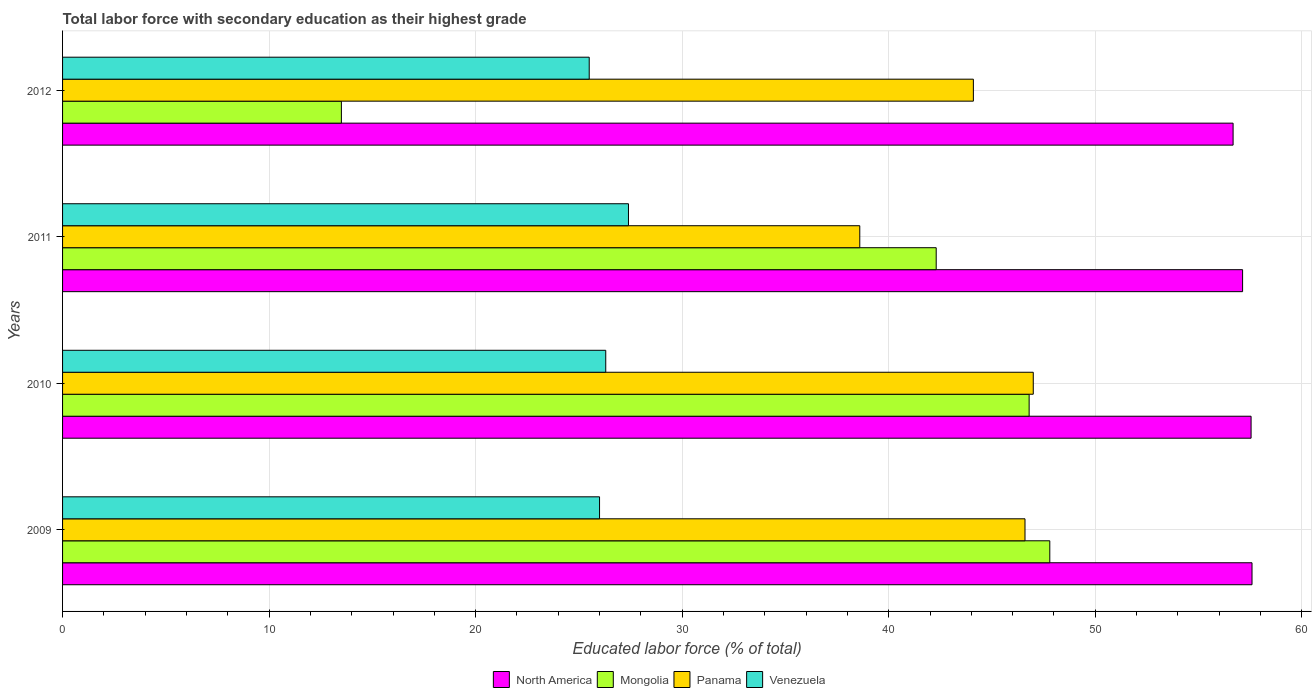Are the number of bars per tick equal to the number of legend labels?
Give a very brief answer. Yes. How many bars are there on the 3rd tick from the top?
Keep it short and to the point. 4. How many bars are there on the 1st tick from the bottom?
Make the answer very short. 4. In how many cases, is the number of bars for a given year not equal to the number of legend labels?
Your answer should be very brief. 0. What is the percentage of total labor force with primary education in Venezuela in 2011?
Give a very brief answer. 27.4. Across all years, what is the minimum percentage of total labor force with primary education in Mongolia?
Your response must be concise. 13.5. In which year was the percentage of total labor force with primary education in Panama minimum?
Ensure brevity in your answer.  2011. What is the total percentage of total labor force with primary education in Mongolia in the graph?
Keep it short and to the point. 150.4. What is the difference between the percentage of total labor force with primary education in North America in 2009 and the percentage of total labor force with primary education in Mongolia in 2012?
Ensure brevity in your answer.  44.09. What is the average percentage of total labor force with primary education in Panama per year?
Keep it short and to the point. 44.07. In the year 2010, what is the difference between the percentage of total labor force with primary education in Panama and percentage of total labor force with primary education in Mongolia?
Ensure brevity in your answer.  0.2. What is the ratio of the percentage of total labor force with primary education in Mongolia in 2009 to that in 2012?
Your answer should be compact. 3.54. Is the percentage of total labor force with primary education in Venezuela in 2010 less than that in 2012?
Ensure brevity in your answer.  No. What is the difference between the highest and the second highest percentage of total labor force with primary education in Panama?
Your answer should be compact. 0.4. What is the difference between the highest and the lowest percentage of total labor force with primary education in Mongolia?
Give a very brief answer. 34.3. What does the 3rd bar from the top in 2011 represents?
Offer a very short reply. Mongolia. What does the 3rd bar from the bottom in 2012 represents?
Provide a short and direct response. Panama. Are all the bars in the graph horizontal?
Your response must be concise. Yes. How many years are there in the graph?
Offer a terse response. 4. What is the difference between two consecutive major ticks on the X-axis?
Provide a succinct answer. 10. Does the graph contain any zero values?
Your answer should be very brief. No. Does the graph contain grids?
Provide a succinct answer. Yes. How many legend labels are there?
Provide a succinct answer. 4. How are the legend labels stacked?
Keep it short and to the point. Horizontal. What is the title of the graph?
Your response must be concise. Total labor force with secondary education as their highest grade. What is the label or title of the X-axis?
Your answer should be very brief. Educated labor force (% of total). What is the Educated labor force (% of total) of North America in 2009?
Give a very brief answer. 57.59. What is the Educated labor force (% of total) of Mongolia in 2009?
Your answer should be compact. 47.8. What is the Educated labor force (% of total) of Panama in 2009?
Your answer should be compact. 46.6. What is the Educated labor force (% of total) of North America in 2010?
Offer a very short reply. 57.55. What is the Educated labor force (% of total) in Mongolia in 2010?
Offer a very short reply. 46.8. What is the Educated labor force (% of total) in Panama in 2010?
Your response must be concise. 47. What is the Educated labor force (% of total) of Venezuela in 2010?
Provide a succinct answer. 26.3. What is the Educated labor force (% of total) of North America in 2011?
Your answer should be very brief. 57.14. What is the Educated labor force (% of total) in Mongolia in 2011?
Provide a short and direct response. 42.3. What is the Educated labor force (% of total) of Panama in 2011?
Your answer should be compact. 38.6. What is the Educated labor force (% of total) in Venezuela in 2011?
Offer a very short reply. 27.4. What is the Educated labor force (% of total) of North America in 2012?
Your answer should be very brief. 56.67. What is the Educated labor force (% of total) in Panama in 2012?
Keep it short and to the point. 44.1. Across all years, what is the maximum Educated labor force (% of total) in North America?
Ensure brevity in your answer.  57.59. Across all years, what is the maximum Educated labor force (% of total) of Mongolia?
Keep it short and to the point. 47.8. Across all years, what is the maximum Educated labor force (% of total) of Venezuela?
Provide a succinct answer. 27.4. Across all years, what is the minimum Educated labor force (% of total) in North America?
Ensure brevity in your answer.  56.67. Across all years, what is the minimum Educated labor force (% of total) of Mongolia?
Provide a succinct answer. 13.5. Across all years, what is the minimum Educated labor force (% of total) of Panama?
Keep it short and to the point. 38.6. Across all years, what is the minimum Educated labor force (% of total) in Venezuela?
Keep it short and to the point. 25.5. What is the total Educated labor force (% of total) of North America in the graph?
Your answer should be compact. 228.95. What is the total Educated labor force (% of total) in Mongolia in the graph?
Keep it short and to the point. 150.4. What is the total Educated labor force (% of total) in Panama in the graph?
Your answer should be compact. 176.3. What is the total Educated labor force (% of total) of Venezuela in the graph?
Offer a very short reply. 105.2. What is the difference between the Educated labor force (% of total) in North America in 2009 and that in 2010?
Give a very brief answer. 0.05. What is the difference between the Educated labor force (% of total) of Panama in 2009 and that in 2010?
Give a very brief answer. -0.4. What is the difference between the Educated labor force (% of total) in Venezuela in 2009 and that in 2010?
Offer a very short reply. -0.3. What is the difference between the Educated labor force (% of total) in North America in 2009 and that in 2011?
Offer a terse response. 0.46. What is the difference between the Educated labor force (% of total) in Mongolia in 2009 and that in 2011?
Ensure brevity in your answer.  5.5. What is the difference between the Educated labor force (% of total) of Mongolia in 2009 and that in 2012?
Provide a succinct answer. 34.3. What is the difference between the Educated labor force (% of total) of Venezuela in 2009 and that in 2012?
Ensure brevity in your answer.  0.5. What is the difference between the Educated labor force (% of total) of North America in 2010 and that in 2011?
Offer a very short reply. 0.41. What is the difference between the Educated labor force (% of total) of North America in 2010 and that in 2012?
Ensure brevity in your answer.  0.87. What is the difference between the Educated labor force (% of total) in Mongolia in 2010 and that in 2012?
Your response must be concise. 33.3. What is the difference between the Educated labor force (% of total) of Venezuela in 2010 and that in 2012?
Keep it short and to the point. 0.8. What is the difference between the Educated labor force (% of total) of North America in 2011 and that in 2012?
Give a very brief answer. 0.46. What is the difference between the Educated labor force (% of total) of Mongolia in 2011 and that in 2012?
Make the answer very short. 28.8. What is the difference between the Educated labor force (% of total) of North America in 2009 and the Educated labor force (% of total) of Mongolia in 2010?
Ensure brevity in your answer.  10.79. What is the difference between the Educated labor force (% of total) in North America in 2009 and the Educated labor force (% of total) in Panama in 2010?
Offer a terse response. 10.59. What is the difference between the Educated labor force (% of total) in North America in 2009 and the Educated labor force (% of total) in Venezuela in 2010?
Make the answer very short. 31.29. What is the difference between the Educated labor force (% of total) of Panama in 2009 and the Educated labor force (% of total) of Venezuela in 2010?
Keep it short and to the point. 20.3. What is the difference between the Educated labor force (% of total) in North America in 2009 and the Educated labor force (% of total) in Mongolia in 2011?
Offer a terse response. 15.29. What is the difference between the Educated labor force (% of total) of North America in 2009 and the Educated labor force (% of total) of Panama in 2011?
Offer a very short reply. 18.99. What is the difference between the Educated labor force (% of total) of North America in 2009 and the Educated labor force (% of total) of Venezuela in 2011?
Give a very brief answer. 30.19. What is the difference between the Educated labor force (% of total) of Mongolia in 2009 and the Educated labor force (% of total) of Panama in 2011?
Provide a succinct answer. 9.2. What is the difference between the Educated labor force (% of total) of Mongolia in 2009 and the Educated labor force (% of total) of Venezuela in 2011?
Give a very brief answer. 20.4. What is the difference between the Educated labor force (% of total) in North America in 2009 and the Educated labor force (% of total) in Mongolia in 2012?
Keep it short and to the point. 44.09. What is the difference between the Educated labor force (% of total) in North America in 2009 and the Educated labor force (% of total) in Panama in 2012?
Offer a terse response. 13.49. What is the difference between the Educated labor force (% of total) in North America in 2009 and the Educated labor force (% of total) in Venezuela in 2012?
Give a very brief answer. 32.09. What is the difference between the Educated labor force (% of total) in Mongolia in 2009 and the Educated labor force (% of total) in Venezuela in 2012?
Your answer should be very brief. 22.3. What is the difference between the Educated labor force (% of total) in Panama in 2009 and the Educated labor force (% of total) in Venezuela in 2012?
Give a very brief answer. 21.1. What is the difference between the Educated labor force (% of total) of North America in 2010 and the Educated labor force (% of total) of Mongolia in 2011?
Your answer should be compact. 15.25. What is the difference between the Educated labor force (% of total) in North America in 2010 and the Educated labor force (% of total) in Panama in 2011?
Keep it short and to the point. 18.95. What is the difference between the Educated labor force (% of total) of North America in 2010 and the Educated labor force (% of total) of Venezuela in 2011?
Your answer should be compact. 30.15. What is the difference between the Educated labor force (% of total) of Mongolia in 2010 and the Educated labor force (% of total) of Venezuela in 2011?
Provide a succinct answer. 19.4. What is the difference between the Educated labor force (% of total) of Panama in 2010 and the Educated labor force (% of total) of Venezuela in 2011?
Keep it short and to the point. 19.6. What is the difference between the Educated labor force (% of total) in North America in 2010 and the Educated labor force (% of total) in Mongolia in 2012?
Provide a succinct answer. 44.05. What is the difference between the Educated labor force (% of total) of North America in 2010 and the Educated labor force (% of total) of Panama in 2012?
Your answer should be compact. 13.45. What is the difference between the Educated labor force (% of total) of North America in 2010 and the Educated labor force (% of total) of Venezuela in 2012?
Provide a succinct answer. 32.05. What is the difference between the Educated labor force (% of total) of Mongolia in 2010 and the Educated labor force (% of total) of Venezuela in 2012?
Give a very brief answer. 21.3. What is the difference between the Educated labor force (% of total) of North America in 2011 and the Educated labor force (% of total) of Mongolia in 2012?
Give a very brief answer. 43.64. What is the difference between the Educated labor force (% of total) of North America in 2011 and the Educated labor force (% of total) of Panama in 2012?
Provide a succinct answer. 13.04. What is the difference between the Educated labor force (% of total) of North America in 2011 and the Educated labor force (% of total) of Venezuela in 2012?
Offer a terse response. 31.64. What is the difference between the Educated labor force (% of total) of Mongolia in 2011 and the Educated labor force (% of total) of Panama in 2012?
Give a very brief answer. -1.8. What is the difference between the Educated labor force (% of total) in Panama in 2011 and the Educated labor force (% of total) in Venezuela in 2012?
Give a very brief answer. 13.1. What is the average Educated labor force (% of total) of North America per year?
Offer a very short reply. 57.24. What is the average Educated labor force (% of total) in Mongolia per year?
Your response must be concise. 37.6. What is the average Educated labor force (% of total) in Panama per year?
Ensure brevity in your answer.  44.08. What is the average Educated labor force (% of total) of Venezuela per year?
Your answer should be very brief. 26.3. In the year 2009, what is the difference between the Educated labor force (% of total) in North America and Educated labor force (% of total) in Mongolia?
Make the answer very short. 9.79. In the year 2009, what is the difference between the Educated labor force (% of total) in North America and Educated labor force (% of total) in Panama?
Make the answer very short. 10.99. In the year 2009, what is the difference between the Educated labor force (% of total) of North America and Educated labor force (% of total) of Venezuela?
Offer a very short reply. 31.59. In the year 2009, what is the difference between the Educated labor force (% of total) in Mongolia and Educated labor force (% of total) in Venezuela?
Give a very brief answer. 21.8. In the year 2009, what is the difference between the Educated labor force (% of total) of Panama and Educated labor force (% of total) of Venezuela?
Your answer should be compact. 20.6. In the year 2010, what is the difference between the Educated labor force (% of total) of North America and Educated labor force (% of total) of Mongolia?
Keep it short and to the point. 10.75. In the year 2010, what is the difference between the Educated labor force (% of total) of North America and Educated labor force (% of total) of Panama?
Your response must be concise. 10.55. In the year 2010, what is the difference between the Educated labor force (% of total) of North America and Educated labor force (% of total) of Venezuela?
Offer a terse response. 31.25. In the year 2010, what is the difference between the Educated labor force (% of total) of Mongolia and Educated labor force (% of total) of Panama?
Provide a short and direct response. -0.2. In the year 2010, what is the difference between the Educated labor force (% of total) of Panama and Educated labor force (% of total) of Venezuela?
Provide a short and direct response. 20.7. In the year 2011, what is the difference between the Educated labor force (% of total) in North America and Educated labor force (% of total) in Mongolia?
Provide a succinct answer. 14.84. In the year 2011, what is the difference between the Educated labor force (% of total) of North America and Educated labor force (% of total) of Panama?
Ensure brevity in your answer.  18.54. In the year 2011, what is the difference between the Educated labor force (% of total) of North America and Educated labor force (% of total) of Venezuela?
Your answer should be very brief. 29.74. In the year 2011, what is the difference between the Educated labor force (% of total) of Mongolia and Educated labor force (% of total) of Venezuela?
Make the answer very short. 14.9. In the year 2012, what is the difference between the Educated labor force (% of total) of North America and Educated labor force (% of total) of Mongolia?
Ensure brevity in your answer.  43.17. In the year 2012, what is the difference between the Educated labor force (% of total) of North America and Educated labor force (% of total) of Panama?
Keep it short and to the point. 12.57. In the year 2012, what is the difference between the Educated labor force (% of total) of North America and Educated labor force (% of total) of Venezuela?
Your response must be concise. 31.18. In the year 2012, what is the difference between the Educated labor force (% of total) in Mongolia and Educated labor force (% of total) in Panama?
Give a very brief answer. -30.6. In the year 2012, what is the difference between the Educated labor force (% of total) in Mongolia and Educated labor force (% of total) in Venezuela?
Offer a terse response. -12. What is the ratio of the Educated labor force (% of total) in Mongolia in 2009 to that in 2010?
Provide a short and direct response. 1.02. What is the ratio of the Educated labor force (% of total) of Venezuela in 2009 to that in 2010?
Your response must be concise. 0.99. What is the ratio of the Educated labor force (% of total) in Mongolia in 2009 to that in 2011?
Provide a short and direct response. 1.13. What is the ratio of the Educated labor force (% of total) of Panama in 2009 to that in 2011?
Give a very brief answer. 1.21. What is the ratio of the Educated labor force (% of total) of Venezuela in 2009 to that in 2011?
Provide a succinct answer. 0.95. What is the ratio of the Educated labor force (% of total) of North America in 2009 to that in 2012?
Provide a succinct answer. 1.02. What is the ratio of the Educated labor force (% of total) of Mongolia in 2009 to that in 2012?
Keep it short and to the point. 3.54. What is the ratio of the Educated labor force (% of total) in Panama in 2009 to that in 2012?
Provide a short and direct response. 1.06. What is the ratio of the Educated labor force (% of total) in Venezuela in 2009 to that in 2012?
Ensure brevity in your answer.  1.02. What is the ratio of the Educated labor force (% of total) in North America in 2010 to that in 2011?
Keep it short and to the point. 1.01. What is the ratio of the Educated labor force (% of total) in Mongolia in 2010 to that in 2011?
Offer a terse response. 1.11. What is the ratio of the Educated labor force (% of total) of Panama in 2010 to that in 2011?
Offer a terse response. 1.22. What is the ratio of the Educated labor force (% of total) in Venezuela in 2010 to that in 2011?
Ensure brevity in your answer.  0.96. What is the ratio of the Educated labor force (% of total) in North America in 2010 to that in 2012?
Provide a succinct answer. 1.02. What is the ratio of the Educated labor force (% of total) of Mongolia in 2010 to that in 2012?
Ensure brevity in your answer.  3.47. What is the ratio of the Educated labor force (% of total) in Panama in 2010 to that in 2012?
Your answer should be compact. 1.07. What is the ratio of the Educated labor force (% of total) in Venezuela in 2010 to that in 2012?
Your answer should be compact. 1.03. What is the ratio of the Educated labor force (% of total) in Mongolia in 2011 to that in 2012?
Keep it short and to the point. 3.13. What is the ratio of the Educated labor force (% of total) of Panama in 2011 to that in 2012?
Your response must be concise. 0.88. What is the ratio of the Educated labor force (% of total) in Venezuela in 2011 to that in 2012?
Your answer should be very brief. 1.07. What is the difference between the highest and the second highest Educated labor force (% of total) of North America?
Give a very brief answer. 0.05. What is the difference between the highest and the second highest Educated labor force (% of total) of Mongolia?
Keep it short and to the point. 1. What is the difference between the highest and the second highest Educated labor force (% of total) of Venezuela?
Make the answer very short. 1.1. What is the difference between the highest and the lowest Educated labor force (% of total) in North America?
Your answer should be compact. 0.92. What is the difference between the highest and the lowest Educated labor force (% of total) in Mongolia?
Offer a terse response. 34.3. 